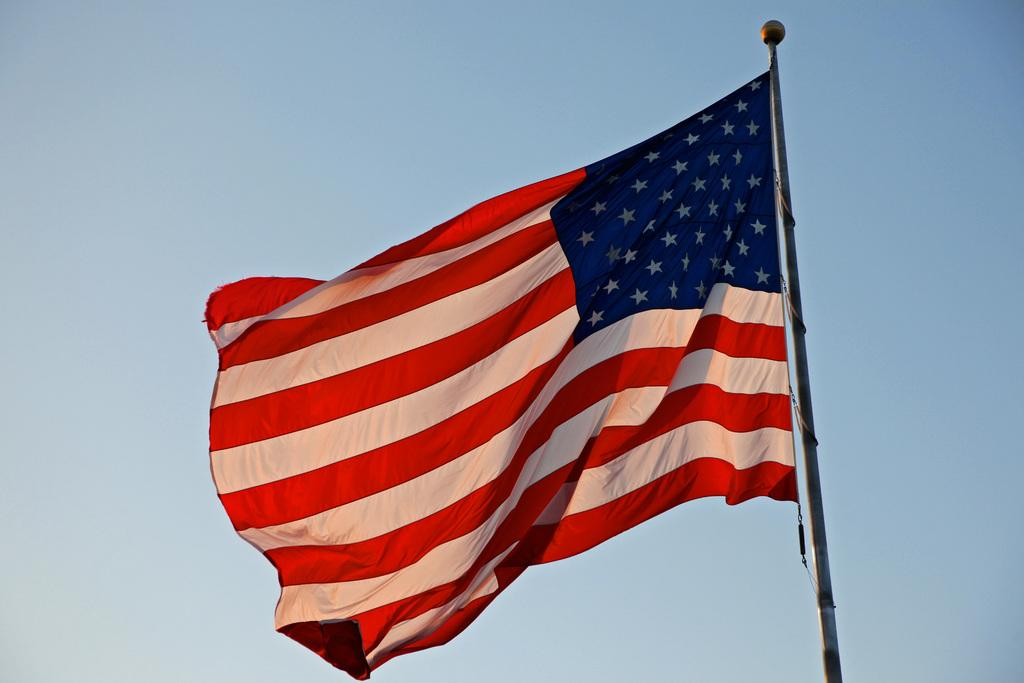What object is present in the image that represents a country or organization? There is a flag in the image. How is the flag supported or held up in the image? The flag is attached to a pole. What can be seen in the background of the image? The sky is visible behind the flag in the image. Can you tell me how many potatoes are hidden under the flag in the image? There are no potatoes present in the image, and therefore no such objects can be observed. How is the parcel being used in the image? There is no parcel present in the image. 